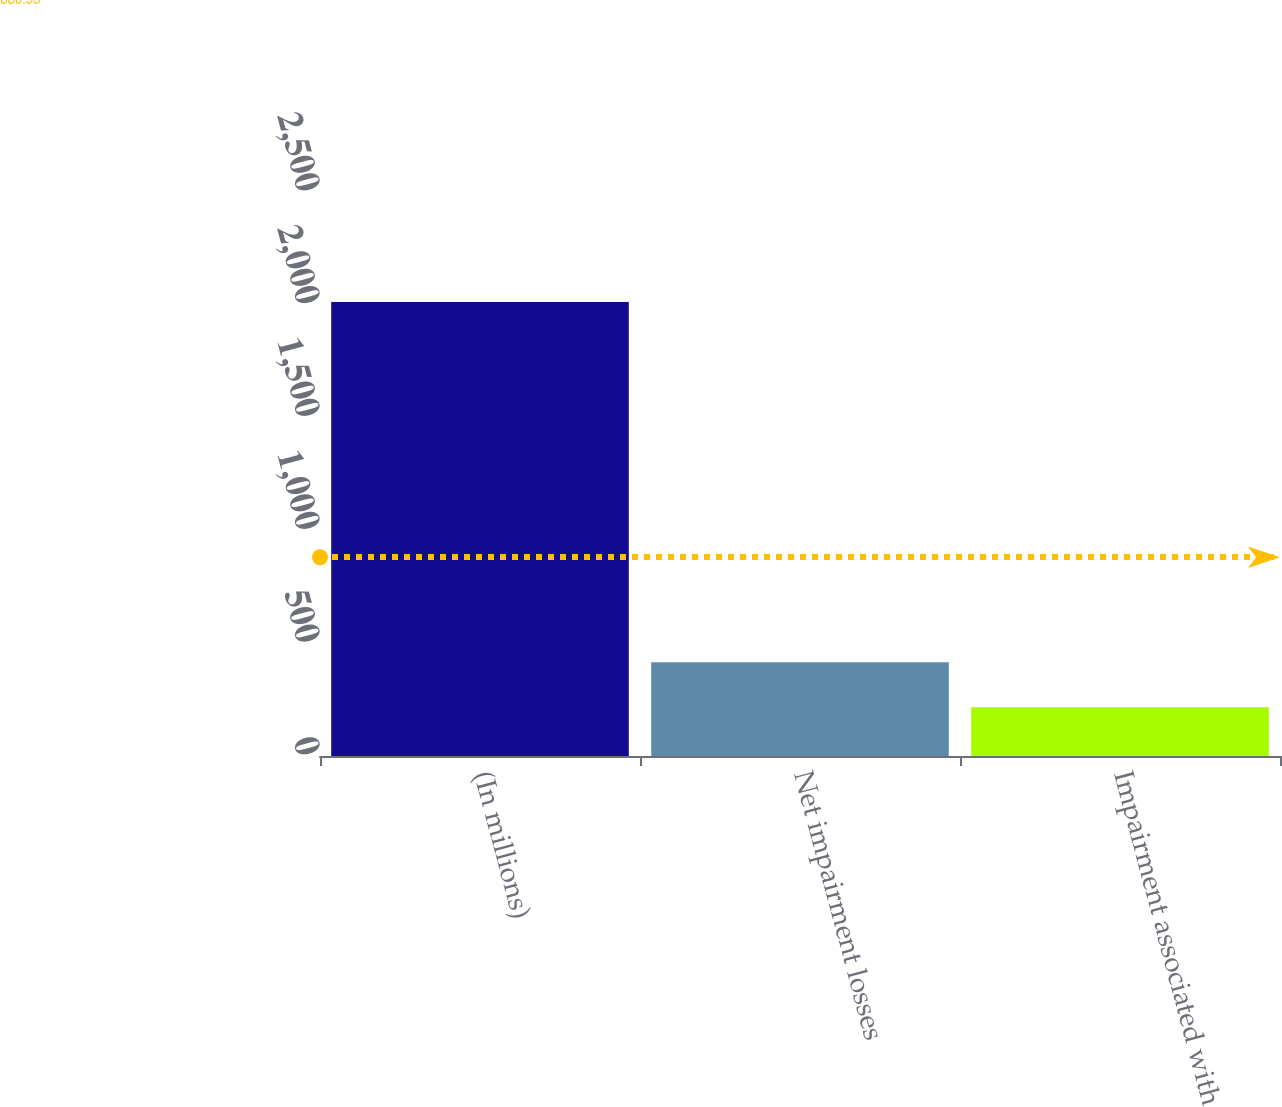Convert chart. <chart><loc_0><loc_0><loc_500><loc_500><bar_chart><fcel>(In millions)<fcel>Net impairment losses<fcel>Impairment associated with<nl><fcel>2012<fcel>415.2<fcel>215.6<nl></chart> 